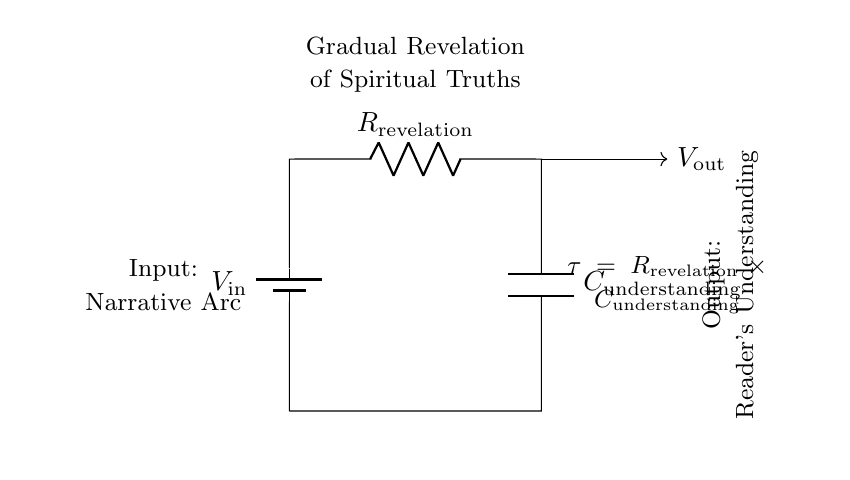What is the input of this circuit? The input is labeled as a narrative arc in the circuit diagram, indicating the source of contextual information leading to understanding.
Answer: Narrative Arc What does \( V_{out} \) represent in this circuit? \( V_{out} \) represents the reader's understanding that is derived from the gradual revelation of spiritual truths as mediated by the circuit components.
Answer: Reader's Understanding What are the components in this circuit? The components in the circuit are a battery, a resistor labeled as \( R_{revelation} \), and a capacitor labeled as \( C_{understanding} \).
Answer: Battery, Resistor, Capacitor What does the time constant \( \tau \) indicate in terms of revelation? The time constant \( \tau \) is calculated as the product of the resistance \( R_{revelation} \) and the capacitance \( C_{understanding} \) and indicates how quickly the understanding forms as the narrative develops.
Answer: \( R_{revelation} \times C_{understanding} \) How do the resistor and capacitor interact in this circuit? The resistor limits the rate of charge transfer to the capacitor, which accumulates voltage over time based on the input narrative arc, thereby gradually revealing the spiritual truths.
Answer: Limits charge rate What is the physical meaning of the circuit's output? The output represents the cumulative effect of the narrative arc being processed, illustrating how the reader’s understanding evolves gradually as new information is revealed.
Answer: Gradual Understanding 